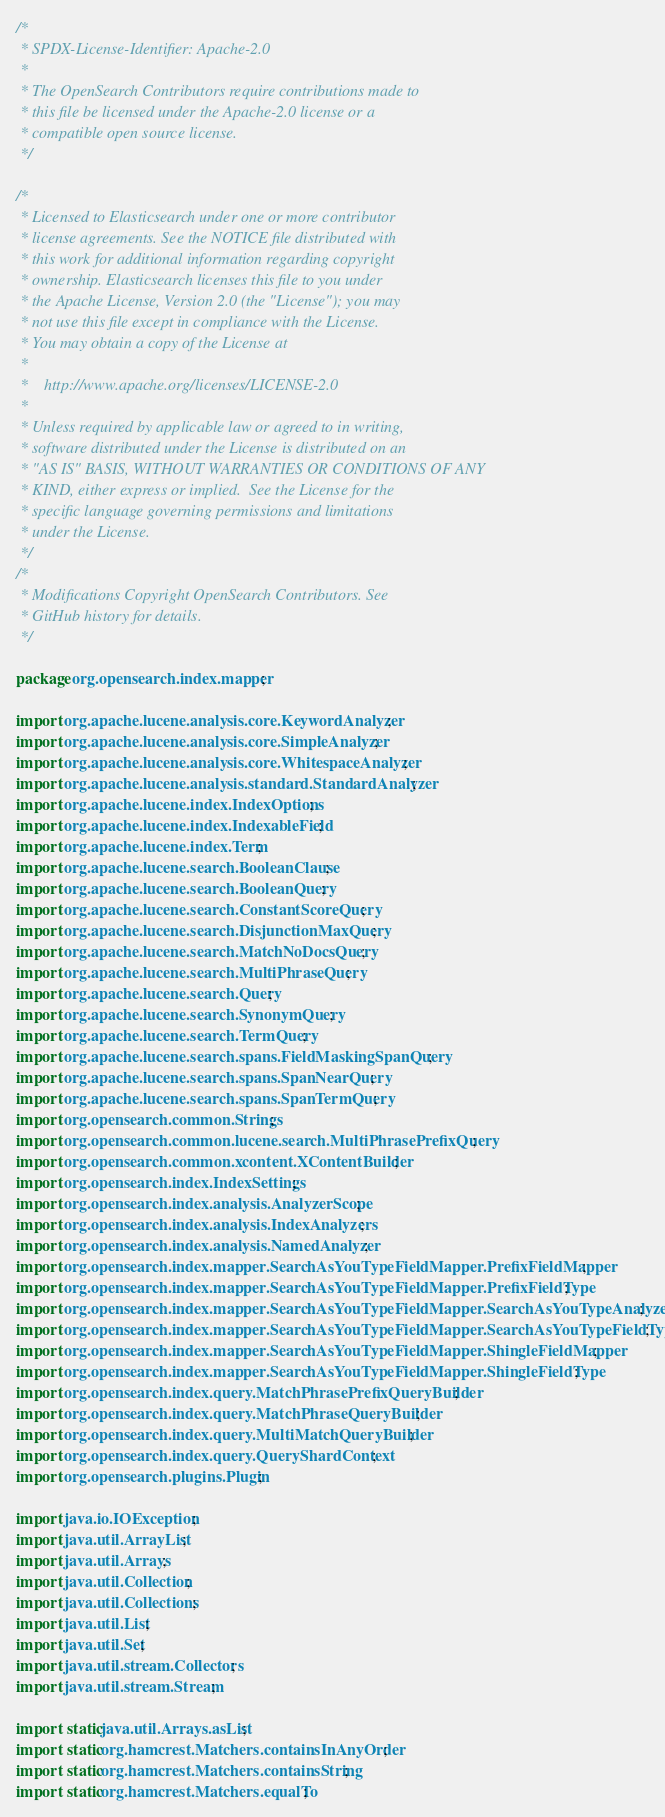<code> <loc_0><loc_0><loc_500><loc_500><_Java_>/*
 * SPDX-License-Identifier: Apache-2.0
 *
 * The OpenSearch Contributors require contributions made to
 * this file be licensed under the Apache-2.0 license or a
 * compatible open source license.
 */

/*
 * Licensed to Elasticsearch under one or more contributor
 * license agreements. See the NOTICE file distributed with
 * this work for additional information regarding copyright
 * ownership. Elasticsearch licenses this file to you under
 * the Apache License, Version 2.0 (the "License"); you may
 * not use this file except in compliance with the License.
 * You may obtain a copy of the License at
 *
 *    http://www.apache.org/licenses/LICENSE-2.0
 *
 * Unless required by applicable law or agreed to in writing,
 * software distributed under the License is distributed on an
 * "AS IS" BASIS, WITHOUT WARRANTIES OR CONDITIONS OF ANY
 * KIND, either express or implied.  See the License for the
 * specific language governing permissions and limitations
 * under the License.
 */
/*
 * Modifications Copyright OpenSearch Contributors. See
 * GitHub history for details.
 */

package org.opensearch.index.mapper;

import org.apache.lucene.analysis.core.KeywordAnalyzer;
import org.apache.lucene.analysis.core.SimpleAnalyzer;
import org.apache.lucene.analysis.core.WhitespaceAnalyzer;
import org.apache.lucene.analysis.standard.StandardAnalyzer;
import org.apache.lucene.index.IndexOptions;
import org.apache.lucene.index.IndexableField;
import org.apache.lucene.index.Term;
import org.apache.lucene.search.BooleanClause;
import org.apache.lucene.search.BooleanQuery;
import org.apache.lucene.search.ConstantScoreQuery;
import org.apache.lucene.search.DisjunctionMaxQuery;
import org.apache.lucene.search.MatchNoDocsQuery;
import org.apache.lucene.search.MultiPhraseQuery;
import org.apache.lucene.search.Query;
import org.apache.lucene.search.SynonymQuery;
import org.apache.lucene.search.TermQuery;
import org.apache.lucene.search.spans.FieldMaskingSpanQuery;
import org.apache.lucene.search.spans.SpanNearQuery;
import org.apache.lucene.search.spans.SpanTermQuery;
import org.opensearch.common.Strings;
import org.opensearch.common.lucene.search.MultiPhrasePrefixQuery;
import org.opensearch.common.xcontent.XContentBuilder;
import org.opensearch.index.IndexSettings;
import org.opensearch.index.analysis.AnalyzerScope;
import org.opensearch.index.analysis.IndexAnalyzers;
import org.opensearch.index.analysis.NamedAnalyzer;
import org.opensearch.index.mapper.SearchAsYouTypeFieldMapper.PrefixFieldMapper;
import org.opensearch.index.mapper.SearchAsYouTypeFieldMapper.PrefixFieldType;
import org.opensearch.index.mapper.SearchAsYouTypeFieldMapper.SearchAsYouTypeAnalyzer;
import org.opensearch.index.mapper.SearchAsYouTypeFieldMapper.SearchAsYouTypeFieldType;
import org.opensearch.index.mapper.SearchAsYouTypeFieldMapper.ShingleFieldMapper;
import org.opensearch.index.mapper.SearchAsYouTypeFieldMapper.ShingleFieldType;
import org.opensearch.index.query.MatchPhrasePrefixQueryBuilder;
import org.opensearch.index.query.MatchPhraseQueryBuilder;
import org.opensearch.index.query.MultiMatchQueryBuilder;
import org.opensearch.index.query.QueryShardContext;
import org.opensearch.plugins.Plugin;

import java.io.IOException;
import java.util.ArrayList;
import java.util.Arrays;
import java.util.Collection;
import java.util.Collections;
import java.util.List;
import java.util.Set;
import java.util.stream.Collectors;
import java.util.stream.Stream;

import static java.util.Arrays.asList;
import static org.hamcrest.Matchers.containsInAnyOrder;
import static org.hamcrest.Matchers.containsString;
import static org.hamcrest.Matchers.equalTo;</code> 